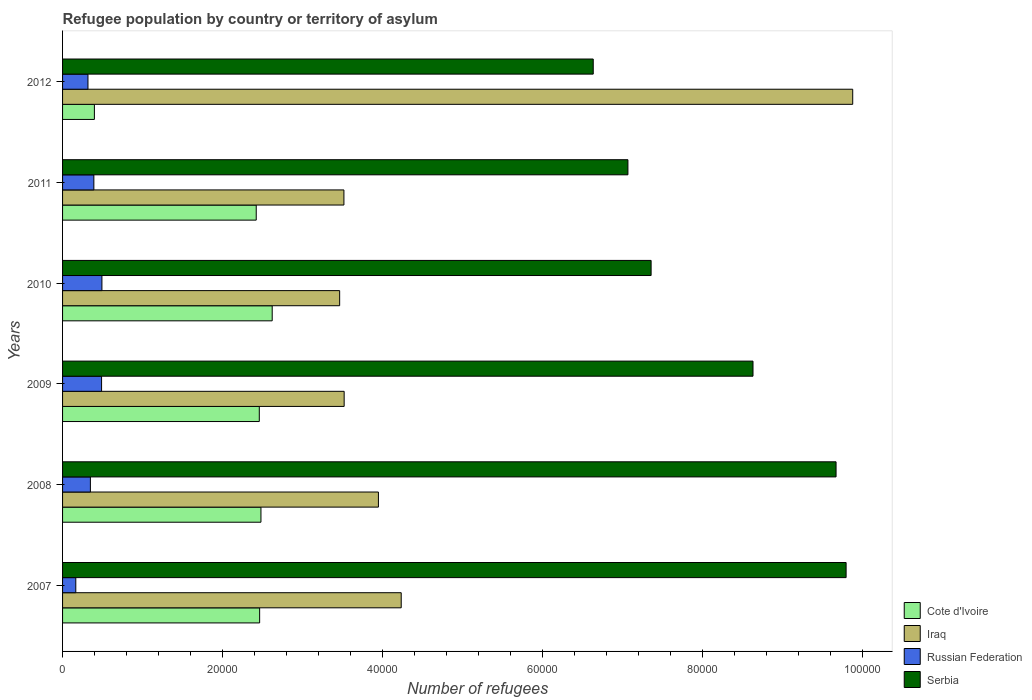How many groups of bars are there?
Your answer should be compact. 6. Are the number of bars per tick equal to the number of legend labels?
Offer a terse response. Yes. How many bars are there on the 5th tick from the top?
Your answer should be compact. 4. In how many cases, is the number of bars for a given year not equal to the number of legend labels?
Offer a very short reply. 0. What is the number of refugees in Iraq in 2009?
Offer a very short reply. 3.52e+04. Across all years, what is the maximum number of refugees in Russian Federation?
Make the answer very short. 4922. Across all years, what is the minimum number of refugees in Russian Federation?
Keep it short and to the point. 1655. What is the total number of refugees in Cote d'Ivoire in the graph?
Your answer should be very brief. 1.28e+05. What is the difference between the number of refugees in Cote d'Ivoire in 2009 and that in 2010?
Make the answer very short. -1614. What is the difference between the number of refugees in Serbia in 2010 and the number of refugees in Cote d'Ivoire in 2012?
Your response must be concise. 6.96e+04. What is the average number of refugees in Russian Federation per year?
Your answer should be compact. 3671.33. In the year 2008, what is the difference between the number of refugees in Russian Federation and number of refugees in Iraq?
Give a very brief answer. -3.60e+04. What is the ratio of the number of refugees in Cote d'Ivoire in 2007 to that in 2008?
Provide a short and direct response. 0.99. Is the number of refugees in Cote d'Ivoire in 2008 less than that in 2011?
Give a very brief answer. No. Is the difference between the number of refugees in Russian Federation in 2008 and 2012 greater than the difference between the number of refugees in Iraq in 2008 and 2012?
Provide a short and direct response. Yes. What is the difference between the highest and the second highest number of refugees in Serbia?
Give a very brief answer. 1256. What is the difference between the highest and the lowest number of refugees in Iraq?
Provide a short and direct response. 6.42e+04. In how many years, is the number of refugees in Iraq greater than the average number of refugees in Iraq taken over all years?
Give a very brief answer. 1. Is the sum of the number of refugees in Cote d'Ivoire in 2009 and 2011 greater than the maximum number of refugees in Iraq across all years?
Offer a very short reply. No. What does the 2nd bar from the top in 2008 represents?
Provide a succinct answer. Russian Federation. What does the 2nd bar from the bottom in 2008 represents?
Ensure brevity in your answer.  Iraq. Is it the case that in every year, the sum of the number of refugees in Iraq and number of refugees in Cote d'Ivoire is greater than the number of refugees in Russian Federation?
Ensure brevity in your answer.  Yes. How many bars are there?
Provide a short and direct response. 24. Are all the bars in the graph horizontal?
Your answer should be compact. Yes. Are the values on the major ticks of X-axis written in scientific E-notation?
Your answer should be compact. No. Does the graph contain grids?
Provide a short and direct response. No. Where does the legend appear in the graph?
Your answer should be compact. Bottom right. How many legend labels are there?
Your answer should be very brief. 4. How are the legend labels stacked?
Offer a terse response. Vertical. What is the title of the graph?
Give a very brief answer. Refugee population by country or territory of asylum. Does "Gabon" appear as one of the legend labels in the graph?
Keep it short and to the point. No. What is the label or title of the X-axis?
Your response must be concise. Number of refugees. What is the label or title of the Y-axis?
Provide a succinct answer. Years. What is the Number of refugees of Cote d'Ivoire in 2007?
Give a very brief answer. 2.46e+04. What is the Number of refugees in Iraq in 2007?
Provide a short and direct response. 4.24e+04. What is the Number of refugees of Russian Federation in 2007?
Offer a terse response. 1655. What is the Number of refugees of Serbia in 2007?
Keep it short and to the point. 9.80e+04. What is the Number of refugees in Cote d'Ivoire in 2008?
Provide a short and direct response. 2.48e+04. What is the Number of refugees in Iraq in 2008?
Provide a succinct answer. 3.95e+04. What is the Number of refugees of Russian Federation in 2008?
Your answer should be compact. 3479. What is the Number of refugees of Serbia in 2008?
Offer a very short reply. 9.67e+04. What is the Number of refugees in Cote d'Ivoire in 2009?
Your answer should be very brief. 2.46e+04. What is the Number of refugees of Iraq in 2009?
Your response must be concise. 3.52e+04. What is the Number of refugees in Russian Federation in 2009?
Offer a terse response. 4880. What is the Number of refugees in Serbia in 2009?
Ensure brevity in your answer.  8.64e+04. What is the Number of refugees of Cote d'Ivoire in 2010?
Make the answer very short. 2.62e+04. What is the Number of refugees of Iraq in 2010?
Give a very brief answer. 3.47e+04. What is the Number of refugees in Russian Federation in 2010?
Your answer should be very brief. 4922. What is the Number of refugees in Serbia in 2010?
Provide a short and direct response. 7.36e+04. What is the Number of refugees in Cote d'Ivoire in 2011?
Your response must be concise. 2.42e+04. What is the Number of refugees in Iraq in 2011?
Your answer should be compact. 3.52e+04. What is the Number of refugees in Russian Federation in 2011?
Keep it short and to the point. 3914. What is the Number of refugees in Serbia in 2011?
Provide a succinct answer. 7.07e+04. What is the Number of refugees of Cote d'Ivoire in 2012?
Your answer should be compact. 3980. What is the Number of refugees of Iraq in 2012?
Provide a succinct answer. 9.88e+04. What is the Number of refugees of Russian Federation in 2012?
Keep it short and to the point. 3178. What is the Number of refugees of Serbia in 2012?
Your answer should be compact. 6.64e+04. Across all years, what is the maximum Number of refugees of Cote d'Ivoire?
Make the answer very short. 2.62e+04. Across all years, what is the maximum Number of refugees of Iraq?
Give a very brief answer. 9.88e+04. Across all years, what is the maximum Number of refugees of Russian Federation?
Your answer should be compact. 4922. Across all years, what is the maximum Number of refugees in Serbia?
Your response must be concise. 9.80e+04. Across all years, what is the minimum Number of refugees in Cote d'Ivoire?
Keep it short and to the point. 3980. Across all years, what is the minimum Number of refugees of Iraq?
Provide a succinct answer. 3.47e+04. Across all years, what is the minimum Number of refugees of Russian Federation?
Ensure brevity in your answer.  1655. Across all years, what is the minimum Number of refugees of Serbia?
Your answer should be very brief. 6.64e+04. What is the total Number of refugees in Cote d'Ivoire in the graph?
Offer a very short reply. 1.28e+05. What is the total Number of refugees in Iraq in the graph?
Your response must be concise. 2.86e+05. What is the total Number of refugees of Russian Federation in the graph?
Give a very brief answer. 2.20e+04. What is the total Number of refugees of Serbia in the graph?
Offer a very short reply. 4.92e+05. What is the difference between the Number of refugees in Cote d'Ivoire in 2007 and that in 2008?
Your answer should be compact. -164. What is the difference between the Number of refugees of Iraq in 2007 and that in 2008?
Ensure brevity in your answer.  2851. What is the difference between the Number of refugees of Russian Federation in 2007 and that in 2008?
Ensure brevity in your answer.  -1824. What is the difference between the Number of refugees in Serbia in 2007 and that in 2008?
Your answer should be compact. 1256. What is the difference between the Number of refugees of Cote d'Ivoire in 2007 and that in 2009?
Provide a short and direct response. 43. What is the difference between the Number of refugees in Iraq in 2007 and that in 2009?
Make the answer very short. 7136. What is the difference between the Number of refugees in Russian Federation in 2007 and that in 2009?
Keep it short and to the point. -3225. What is the difference between the Number of refugees of Serbia in 2007 and that in 2009?
Your response must be concise. 1.16e+04. What is the difference between the Number of refugees in Cote d'Ivoire in 2007 and that in 2010?
Offer a very short reply. -1571. What is the difference between the Number of refugees in Iraq in 2007 and that in 2010?
Your answer should be very brief. 7699. What is the difference between the Number of refugees of Russian Federation in 2007 and that in 2010?
Offer a very short reply. -3267. What is the difference between the Number of refugees of Serbia in 2007 and that in 2010?
Give a very brief answer. 2.44e+04. What is the difference between the Number of refugees in Cote d'Ivoire in 2007 and that in 2011?
Provide a succinct answer. 426. What is the difference between the Number of refugees of Iraq in 2007 and that in 2011?
Your answer should be compact. 7165. What is the difference between the Number of refugees of Russian Federation in 2007 and that in 2011?
Offer a terse response. -2259. What is the difference between the Number of refugees of Serbia in 2007 and that in 2011?
Offer a very short reply. 2.73e+04. What is the difference between the Number of refugees in Cote d'Ivoire in 2007 and that in 2012?
Provide a short and direct response. 2.07e+04. What is the difference between the Number of refugees of Iraq in 2007 and that in 2012?
Offer a very short reply. -5.65e+04. What is the difference between the Number of refugees in Russian Federation in 2007 and that in 2012?
Make the answer very short. -1523. What is the difference between the Number of refugees of Serbia in 2007 and that in 2012?
Your response must be concise. 3.16e+04. What is the difference between the Number of refugees in Cote d'Ivoire in 2008 and that in 2009?
Your answer should be compact. 207. What is the difference between the Number of refugees in Iraq in 2008 and that in 2009?
Ensure brevity in your answer.  4285. What is the difference between the Number of refugees of Russian Federation in 2008 and that in 2009?
Provide a succinct answer. -1401. What is the difference between the Number of refugees in Serbia in 2008 and that in 2009?
Offer a terse response. 1.04e+04. What is the difference between the Number of refugees of Cote d'Ivoire in 2008 and that in 2010?
Your answer should be compact. -1407. What is the difference between the Number of refugees in Iraq in 2008 and that in 2010?
Keep it short and to the point. 4848. What is the difference between the Number of refugees in Russian Federation in 2008 and that in 2010?
Provide a short and direct response. -1443. What is the difference between the Number of refugees in Serbia in 2008 and that in 2010?
Your answer should be very brief. 2.31e+04. What is the difference between the Number of refugees of Cote d'Ivoire in 2008 and that in 2011?
Your answer should be very brief. 590. What is the difference between the Number of refugees of Iraq in 2008 and that in 2011?
Your answer should be very brief. 4314. What is the difference between the Number of refugees in Russian Federation in 2008 and that in 2011?
Your answer should be very brief. -435. What is the difference between the Number of refugees in Serbia in 2008 and that in 2011?
Provide a short and direct response. 2.60e+04. What is the difference between the Number of refugees of Cote d'Ivoire in 2008 and that in 2012?
Provide a succinct answer. 2.08e+04. What is the difference between the Number of refugees in Iraq in 2008 and that in 2012?
Provide a short and direct response. -5.93e+04. What is the difference between the Number of refugees in Russian Federation in 2008 and that in 2012?
Your answer should be compact. 301. What is the difference between the Number of refugees in Serbia in 2008 and that in 2012?
Provide a succinct answer. 3.04e+04. What is the difference between the Number of refugees in Cote d'Ivoire in 2009 and that in 2010?
Offer a terse response. -1614. What is the difference between the Number of refugees of Iraq in 2009 and that in 2010?
Keep it short and to the point. 563. What is the difference between the Number of refugees of Russian Federation in 2009 and that in 2010?
Give a very brief answer. -42. What is the difference between the Number of refugees of Serbia in 2009 and that in 2010?
Offer a terse response. 1.27e+04. What is the difference between the Number of refugees of Cote d'Ivoire in 2009 and that in 2011?
Offer a very short reply. 383. What is the difference between the Number of refugees in Iraq in 2009 and that in 2011?
Ensure brevity in your answer.  29. What is the difference between the Number of refugees of Russian Federation in 2009 and that in 2011?
Provide a short and direct response. 966. What is the difference between the Number of refugees of Serbia in 2009 and that in 2011?
Your response must be concise. 1.56e+04. What is the difference between the Number of refugees of Cote d'Ivoire in 2009 and that in 2012?
Ensure brevity in your answer.  2.06e+04. What is the difference between the Number of refugees in Iraq in 2009 and that in 2012?
Offer a very short reply. -6.36e+04. What is the difference between the Number of refugees of Russian Federation in 2009 and that in 2012?
Offer a terse response. 1702. What is the difference between the Number of refugees of Serbia in 2009 and that in 2012?
Offer a very short reply. 2.00e+04. What is the difference between the Number of refugees of Cote d'Ivoire in 2010 and that in 2011?
Make the answer very short. 1997. What is the difference between the Number of refugees in Iraq in 2010 and that in 2011?
Your response must be concise. -534. What is the difference between the Number of refugees in Russian Federation in 2010 and that in 2011?
Provide a short and direct response. 1008. What is the difference between the Number of refugees in Serbia in 2010 and that in 2011?
Make the answer very short. 2901. What is the difference between the Number of refugees in Cote d'Ivoire in 2010 and that in 2012?
Provide a short and direct response. 2.22e+04. What is the difference between the Number of refugees in Iraq in 2010 and that in 2012?
Offer a terse response. -6.42e+04. What is the difference between the Number of refugees of Russian Federation in 2010 and that in 2012?
Make the answer very short. 1744. What is the difference between the Number of refugees of Serbia in 2010 and that in 2012?
Give a very brief answer. 7238. What is the difference between the Number of refugees in Cote d'Ivoire in 2011 and that in 2012?
Your answer should be compact. 2.02e+04. What is the difference between the Number of refugees of Iraq in 2011 and that in 2012?
Your answer should be very brief. -6.36e+04. What is the difference between the Number of refugees in Russian Federation in 2011 and that in 2012?
Your answer should be compact. 736. What is the difference between the Number of refugees in Serbia in 2011 and that in 2012?
Ensure brevity in your answer.  4337. What is the difference between the Number of refugees of Cote d'Ivoire in 2007 and the Number of refugees of Iraq in 2008?
Your response must be concise. -1.49e+04. What is the difference between the Number of refugees of Cote d'Ivoire in 2007 and the Number of refugees of Russian Federation in 2008?
Give a very brief answer. 2.12e+04. What is the difference between the Number of refugees in Cote d'Ivoire in 2007 and the Number of refugees in Serbia in 2008?
Offer a very short reply. -7.21e+04. What is the difference between the Number of refugees in Iraq in 2007 and the Number of refugees in Russian Federation in 2008?
Offer a very short reply. 3.89e+04. What is the difference between the Number of refugees in Iraq in 2007 and the Number of refugees in Serbia in 2008?
Your response must be concise. -5.44e+04. What is the difference between the Number of refugees in Russian Federation in 2007 and the Number of refugees in Serbia in 2008?
Ensure brevity in your answer.  -9.51e+04. What is the difference between the Number of refugees of Cote d'Ivoire in 2007 and the Number of refugees of Iraq in 2009?
Ensure brevity in your answer.  -1.06e+04. What is the difference between the Number of refugees in Cote d'Ivoire in 2007 and the Number of refugees in Russian Federation in 2009?
Ensure brevity in your answer.  1.98e+04. What is the difference between the Number of refugees in Cote d'Ivoire in 2007 and the Number of refugees in Serbia in 2009?
Ensure brevity in your answer.  -6.17e+04. What is the difference between the Number of refugees in Iraq in 2007 and the Number of refugees in Russian Federation in 2009?
Your response must be concise. 3.75e+04. What is the difference between the Number of refugees of Iraq in 2007 and the Number of refugees of Serbia in 2009?
Keep it short and to the point. -4.40e+04. What is the difference between the Number of refugees of Russian Federation in 2007 and the Number of refugees of Serbia in 2009?
Ensure brevity in your answer.  -8.47e+04. What is the difference between the Number of refugees of Cote d'Ivoire in 2007 and the Number of refugees of Iraq in 2010?
Offer a terse response. -1.00e+04. What is the difference between the Number of refugees in Cote d'Ivoire in 2007 and the Number of refugees in Russian Federation in 2010?
Your answer should be very brief. 1.97e+04. What is the difference between the Number of refugees in Cote d'Ivoire in 2007 and the Number of refugees in Serbia in 2010?
Keep it short and to the point. -4.90e+04. What is the difference between the Number of refugees in Iraq in 2007 and the Number of refugees in Russian Federation in 2010?
Make the answer very short. 3.74e+04. What is the difference between the Number of refugees of Iraq in 2007 and the Number of refugees of Serbia in 2010?
Offer a terse response. -3.13e+04. What is the difference between the Number of refugees in Russian Federation in 2007 and the Number of refugees in Serbia in 2010?
Your answer should be very brief. -7.20e+04. What is the difference between the Number of refugees in Cote d'Ivoire in 2007 and the Number of refugees in Iraq in 2011?
Offer a terse response. -1.05e+04. What is the difference between the Number of refugees of Cote d'Ivoire in 2007 and the Number of refugees of Russian Federation in 2011?
Provide a short and direct response. 2.07e+04. What is the difference between the Number of refugees in Cote d'Ivoire in 2007 and the Number of refugees in Serbia in 2011?
Your response must be concise. -4.61e+04. What is the difference between the Number of refugees in Iraq in 2007 and the Number of refugees in Russian Federation in 2011?
Make the answer very short. 3.84e+04. What is the difference between the Number of refugees in Iraq in 2007 and the Number of refugees in Serbia in 2011?
Keep it short and to the point. -2.84e+04. What is the difference between the Number of refugees in Russian Federation in 2007 and the Number of refugees in Serbia in 2011?
Ensure brevity in your answer.  -6.91e+04. What is the difference between the Number of refugees in Cote d'Ivoire in 2007 and the Number of refugees in Iraq in 2012?
Your answer should be very brief. -7.42e+04. What is the difference between the Number of refugees of Cote d'Ivoire in 2007 and the Number of refugees of Russian Federation in 2012?
Make the answer very short. 2.15e+04. What is the difference between the Number of refugees in Cote d'Ivoire in 2007 and the Number of refugees in Serbia in 2012?
Ensure brevity in your answer.  -4.17e+04. What is the difference between the Number of refugees of Iraq in 2007 and the Number of refugees of Russian Federation in 2012?
Offer a very short reply. 3.92e+04. What is the difference between the Number of refugees of Iraq in 2007 and the Number of refugees of Serbia in 2012?
Offer a very short reply. -2.40e+04. What is the difference between the Number of refugees in Russian Federation in 2007 and the Number of refugees in Serbia in 2012?
Your response must be concise. -6.47e+04. What is the difference between the Number of refugees of Cote d'Ivoire in 2008 and the Number of refugees of Iraq in 2009?
Your answer should be very brief. -1.04e+04. What is the difference between the Number of refugees in Cote d'Ivoire in 2008 and the Number of refugees in Russian Federation in 2009?
Provide a succinct answer. 1.99e+04. What is the difference between the Number of refugees of Cote d'Ivoire in 2008 and the Number of refugees of Serbia in 2009?
Your answer should be compact. -6.15e+04. What is the difference between the Number of refugees of Iraq in 2008 and the Number of refugees of Russian Federation in 2009?
Offer a terse response. 3.46e+04. What is the difference between the Number of refugees in Iraq in 2008 and the Number of refugees in Serbia in 2009?
Offer a terse response. -4.68e+04. What is the difference between the Number of refugees of Russian Federation in 2008 and the Number of refugees of Serbia in 2009?
Ensure brevity in your answer.  -8.29e+04. What is the difference between the Number of refugees in Cote d'Ivoire in 2008 and the Number of refugees in Iraq in 2010?
Give a very brief answer. -9844. What is the difference between the Number of refugees in Cote d'Ivoire in 2008 and the Number of refugees in Russian Federation in 2010?
Offer a terse response. 1.99e+04. What is the difference between the Number of refugees of Cote d'Ivoire in 2008 and the Number of refugees of Serbia in 2010?
Offer a very short reply. -4.88e+04. What is the difference between the Number of refugees of Iraq in 2008 and the Number of refugees of Russian Federation in 2010?
Offer a very short reply. 3.46e+04. What is the difference between the Number of refugees of Iraq in 2008 and the Number of refugees of Serbia in 2010?
Keep it short and to the point. -3.41e+04. What is the difference between the Number of refugees in Russian Federation in 2008 and the Number of refugees in Serbia in 2010?
Your answer should be compact. -7.01e+04. What is the difference between the Number of refugees in Cote d'Ivoire in 2008 and the Number of refugees in Iraq in 2011?
Provide a short and direct response. -1.04e+04. What is the difference between the Number of refugees in Cote d'Ivoire in 2008 and the Number of refugees in Russian Federation in 2011?
Your answer should be very brief. 2.09e+04. What is the difference between the Number of refugees of Cote d'Ivoire in 2008 and the Number of refugees of Serbia in 2011?
Your answer should be very brief. -4.59e+04. What is the difference between the Number of refugees in Iraq in 2008 and the Number of refugees in Russian Federation in 2011?
Make the answer very short. 3.56e+04. What is the difference between the Number of refugees of Iraq in 2008 and the Number of refugees of Serbia in 2011?
Offer a terse response. -3.12e+04. What is the difference between the Number of refugees in Russian Federation in 2008 and the Number of refugees in Serbia in 2011?
Offer a terse response. -6.72e+04. What is the difference between the Number of refugees in Cote d'Ivoire in 2008 and the Number of refugees in Iraq in 2012?
Ensure brevity in your answer.  -7.40e+04. What is the difference between the Number of refugees in Cote d'Ivoire in 2008 and the Number of refugees in Russian Federation in 2012?
Make the answer very short. 2.16e+04. What is the difference between the Number of refugees of Cote d'Ivoire in 2008 and the Number of refugees of Serbia in 2012?
Your answer should be very brief. -4.16e+04. What is the difference between the Number of refugees of Iraq in 2008 and the Number of refugees of Russian Federation in 2012?
Give a very brief answer. 3.63e+04. What is the difference between the Number of refugees in Iraq in 2008 and the Number of refugees in Serbia in 2012?
Offer a very short reply. -2.69e+04. What is the difference between the Number of refugees of Russian Federation in 2008 and the Number of refugees of Serbia in 2012?
Give a very brief answer. -6.29e+04. What is the difference between the Number of refugees of Cote d'Ivoire in 2009 and the Number of refugees of Iraq in 2010?
Your answer should be compact. -1.01e+04. What is the difference between the Number of refugees of Cote d'Ivoire in 2009 and the Number of refugees of Russian Federation in 2010?
Provide a short and direct response. 1.97e+04. What is the difference between the Number of refugees in Cote d'Ivoire in 2009 and the Number of refugees in Serbia in 2010?
Keep it short and to the point. -4.90e+04. What is the difference between the Number of refugees in Iraq in 2009 and the Number of refugees in Russian Federation in 2010?
Provide a short and direct response. 3.03e+04. What is the difference between the Number of refugees of Iraq in 2009 and the Number of refugees of Serbia in 2010?
Offer a very short reply. -3.84e+04. What is the difference between the Number of refugees in Russian Federation in 2009 and the Number of refugees in Serbia in 2010?
Ensure brevity in your answer.  -6.87e+04. What is the difference between the Number of refugees of Cote d'Ivoire in 2009 and the Number of refugees of Iraq in 2011?
Offer a very short reply. -1.06e+04. What is the difference between the Number of refugees of Cote d'Ivoire in 2009 and the Number of refugees of Russian Federation in 2011?
Offer a very short reply. 2.07e+04. What is the difference between the Number of refugees in Cote d'Ivoire in 2009 and the Number of refugees in Serbia in 2011?
Give a very brief answer. -4.61e+04. What is the difference between the Number of refugees of Iraq in 2009 and the Number of refugees of Russian Federation in 2011?
Keep it short and to the point. 3.13e+04. What is the difference between the Number of refugees of Iraq in 2009 and the Number of refugees of Serbia in 2011?
Provide a succinct answer. -3.55e+04. What is the difference between the Number of refugees in Russian Federation in 2009 and the Number of refugees in Serbia in 2011?
Give a very brief answer. -6.58e+04. What is the difference between the Number of refugees in Cote d'Ivoire in 2009 and the Number of refugees in Iraq in 2012?
Provide a short and direct response. -7.42e+04. What is the difference between the Number of refugees of Cote d'Ivoire in 2009 and the Number of refugees of Russian Federation in 2012?
Offer a very short reply. 2.14e+04. What is the difference between the Number of refugees of Cote d'Ivoire in 2009 and the Number of refugees of Serbia in 2012?
Offer a terse response. -4.18e+04. What is the difference between the Number of refugees of Iraq in 2009 and the Number of refugees of Russian Federation in 2012?
Your response must be concise. 3.20e+04. What is the difference between the Number of refugees in Iraq in 2009 and the Number of refugees in Serbia in 2012?
Provide a succinct answer. -3.12e+04. What is the difference between the Number of refugees of Russian Federation in 2009 and the Number of refugees of Serbia in 2012?
Your answer should be compact. -6.15e+04. What is the difference between the Number of refugees in Cote d'Ivoire in 2010 and the Number of refugees in Iraq in 2011?
Your response must be concise. -8971. What is the difference between the Number of refugees in Cote d'Ivoire in 2010 and the Number of refugees in Russian Federation in 2011?
Your response must be concise. 2.23e+04. What is the difference between the Number of refugees of Cote d'Ivoire in 2010 and the Number of refugees of Serbia in 2011?
Your response must be concise. -4.45e+04. What is the difference between the Number of refugees in Iraq in 2010 and the Number of refugees in Russian Federation in 2011?
Offer a very short reply. 3.07e+04. What is the difference between the Number of refugees of Iraq in 2010 and the Number of refugees of Serbia in 2011?
Your answer should be very brief. -3.61e+04. What is the difference between the Number of refugees in Russian Federation in 2010 and the Number of refugees in Serbia in 2011?
Your answer should be compact. -6.58e+04. What is the difference between the Number of refugees in Cote d'Ivoire in 2010 and the Number of refugees in Iraq in 2012?
Your response must be concise. -7.26e+04. What is the difference between the Number of refugees of Cote d'Ivoire in 2010 and the Number of refugees of Russian Federation in 2012?
Your answer should be very brief. 2.30e+04. What is the difference between the Number of refugees of Cote d'Ivoire in 2010 and the Number of refugees of Serbia in 2012?
Offer a terse response. -4.02e+04. What is the difference between the Number of refugees in Iraq in 2010 and the Number of refugees in Russian Federation in 2012?
Your answer should be very brief. 3.15e+04. What is the difference between the Number of refugees of Iraq in 2010 and the Number of refugees of Serbia in 2012?
Make the answer very short. -3.17e+04. What is the difference between the Number of refugees of Russian Federation in 2010 and the Number of refugees of Serbia in 2012?
Ensure brevity in your answer.  -6.14e+04. What is the difference between the Number of refugees in Cote d'Ivoire in 2011 and the Number of refugees in Iraq in 2012?
Keep it short and to the point. -7.46e+04. What is the difference between the Number of refugees of Cote d'Ivoire in 2011 and the Number of refugees of Russian Federation in 2012?
Offer a terse response. 2.10e+04. What is the difference between the Number of refugees of Cote d'Ivoire in 2011 and the Number of refugees of Serbia in 2012?
Your answer should be compact. -4.21e+04. What is the difference between the Number of refugees of Iraq in 2011 and the Number of refugees of Russian Federation in 2012?
Provide a succinct answer. 3.20e+04. What is the difference between the Number of refugees of Iraq in 2011 and the Number of refugees of Serbia in 2012?
Give a very brief answer. -3.12e+04. What is the difference between the Number of refugees in Russian Federation in 2011 and the Number of refugees in Serbia in 2012?
Keep it short and to the point. -6.25e+04. What is the average Number of refugees in Cote d'Ivoire per year?
Give a very brief answer. 2.14e+04. What is the average Number of refugees of Iraq per year?
Offer a terse response. 4.76e+04. What is the average Number of refugees of Russian Federation per year?
Your answer should be compact. 3671.33. What is the average Number of refugees in Serbia per year?
Ensure brevity in your answer.  8.20e+04. In the year 2007, what is the difference between the Number of refugees of Cote d'Ivoire and Number of refugees of Iraq?
Make the answer very short. -1.77e+04. In the year 2007, what is the difference between the Number of refugees in Cote d'Ivoire and Number of refugees in Russian Federation?
Offer a very short reply. 2.30e+04. In the year 2007, what is the difference between the Number of refugees of Cote d'Ivoire and Number of refugees of Serbia?
Your answer should be very brief. -7.33e+04. In the year 2007, what is the difference between the Number of refugees in Iraq and Number of refugees in Russian Federation?
Keep it short and to the point. 4.07e+04. In the year 2007, what is the difference between the Number of refugees of Iraq and Number of refugees of Serbia?
Offer a terse response. -5.56e+04. In the year 2007, what is the difference between the Number of refugees of Russian Federation and Number of refugees of Serbia?
Provide a succinct answer. -9.63e+04. In the year 2008, what is the difference between the Number of refugees of Cote d'Ivoire and Number of refugees of Iraq?
Provide a short and direct response. -1.47e+04. In the year 2008, what is the difference between the Number of refugees of Cote d'Ivoire and Number of refugees of Russian Federation?
Offer a terse response. 2.13e+04. In the year 2008, what is the difference between the Number of refugees of Cote d'Ivoire and Number of refugees of Serbia?
Ensure brevity in your answer.  -7.19e+04. In the year 2008, what is the difference between the Number of refugees in Iraq and Number of refugees in Russian Federation?
Make the answer very short. 3.60e+04. In the year 2008, what is the difference between the Number of refugees in Iraq and Number of refugees in Serbia?
Provide a succinct answer. -5.72e+04. In the year 2008, what is the difference between the Number of refugees of Russian Federation and Number of refugees of Serbia?
Make the answer very short. -9.33e+04. In the year 2009, what is the difference between the Number of refugees of Cote d'Ivoire and Number of refugees of Iraq?
Keep it short and to the point. -1.06e+04. In the year 2009, what is the difference between the Number of refugees of Cote d'Ivoire and Number of refugees of Russian Federation?
Make the answer very short. 1.97e+04. In the year 2009, what is the difference between the Number of refugees in Cote d'Ivoire and Number of refugees in Serbia?
Give a very brief answer. -6.17e+04. In the year 2009, what is the difference between the Number of refugees of Iraq and Number of refugees of Russian Federation?
Ensure brevity in your answer.  3.03e+04. In the year 2009, what is the difference between the Number of refugees of Iraq and Number of refugees of Serbia?
Offer a very short reply. -5.11e+04. In the year 2009, what is the difference between the Number of refugees in Russian Federation and Number of refugees in Serbia?
Provide a short and direct response. -8.15e+04. In the year 2010, what is the difference between the Number of refugees of Cote d'Ivoire and Number of refugees of Iraq?
Make the answer very short. -8437. In the year 2010, what is the difference between the Number of refugees in Cote d'Ivoire and Number of refugees in Russian Federation?
Offer a very short reply. 2.13e+04. In the year 2010, what is the difference between the Number of refugees in Cote d'Ivoire and Number of refugees in Serbia?
Ensure brevity in your answer.  -4.74e+04. In the year 2010, what is the difference between the Number of refugees in Iraq and Number of refugees in Russian Federation?
Offer a very short reply. 2.97e+04. In the year 2010, what is the difference between the Number of refugees in Iraq and Number of refugees in Serbia?
Offer a terse response. -3.90e+04. In the year 2010, what is the difference between the Number of refugees in Russian Federation and Number of refugees in Serbia?
Your answer should be compact. -6.87e+04. In the year 2011, what is the difference between the Number of refugees in Cote d'Ivoire and Number of refugees in Iraq?
Your response must be concise. -1.10e+04. In the year 2011, what is the difference between the Number of refugees of Cote d'Ivoire and Number of refugees of Russian Federation?
Provide a short and direct response. 2.03e+04. In the year 2011, what is the difference between the Number of refugees of Cote d'Ivoire and Number of refugees of Serbia?
Make the answer very short. -4.65e+04. In the year 2011, what is the difference between the Number of refugees in Iraq and Number of refugees in Russian Federation?
Offer a very short reply. 3.13e+04. In the year 2011, what is the difference between the Number of refugees in Iraq and Number of refugees in Serbia?
Give a very brief answer. -3.55e+04. In the year 2011, what is the difference between the Number of refugees in Russian Federation and Number of refugees in Serbia?
Your answer should be very brief. -6.68e+04. In the year 2012, what is the difference between the Number of refugees in Cote d'Ivoire and Number of refugees in Iraq?
Ensure brevity in your answer.  -9.48e+04. In the year 2012, what is the difference between the Number of refugees of Cote d'Ivoire and Number of refugees of Russian Federation?
Provide a short and direct response. 802. In the year 2012, what is the difference between the Number of refugees in Cote d'Ivoire and Number of refugees in Serbia?
Ensure brevity in your answer.  -6.24e+04. In the year 2012, what is the difference between the Number of refugees in Iraq and Number of refugees in Russian Federation?
Offer a terse response. 9.56e+04. In the year 2012, what is the difference between the Number of refugees in Iraq and Number of refugees in Serbia?
Provide a short and direct response. 3.25e+04. In the year 2012, what is the difference between the Number of refugees of Russian Federation and Number of refugees of Serbia?
Ensure brevity in your answer.  -6.32e+04. What is the ratio of the Number of refugees of Cote d'Ivoire in 2007 to that in 2008?
Offer a very short reply. 0.99. What is the ratio of the Number of refugees in Iraq in 2007 to that in 2008?
Make the answer very short. 1.07. What is the ratio of the Number of refugees in Russian Federation in 2007 to that in 2008?
Your response must be concise. 0.48. What is the ratio of the Number of refugees in Cote d'Ivoire in 2007 to that in 2009?
Offer a very short reply. 1. What is the ratio of the Number of refugees of Iraq in 2007 to that in 2009?
Give a very brief answer. 1.2. What is the ratio of the Number of refugees of Russian Federation in 2007 to that in 2009?
Your response must be concise. 0.34. What is the ratio of the Number of refugees of Serbia in 2007 to that in 2009?
Provide a succinct answer. 1.13. What is the ratio of the Number of refugees in Cote d'Ivoire in 2007 to that in 2010?
Your answer should be compact. 0.94. What is the ratio of the Number of refugees in Iraq in 2007 to that in 2010?
Your answer should be very brief. 1.22. What is the ratio of the Number of refugees in Russian Federation in 2007 to that in 2010?
Ensure brevity in your answer.  0.34. What is the ratio of the Number of refugees of Serbia in 2007 to that in 2010?
Offer a very short reply. 1.33. What is the ratio of the Number of refugees of Cote d'Ivoire in 2007 to that in 2011?
Provide a succinct answer. 1.02. What is the ratio of the Number of refugees in Iraq in 2007 to that in 2011?
Your answer should be compact. 1.2. What is the ratio of the Number of refugees of Russian Federation in 2007 to that in 2011?
Your answer should be very brief. 0.42. What is the ratio of the Number of refugees in Serbia in 2007 to that in 2011?
Make the answer very short. 1.39. What is the ratio of the Number of refugees of Cote d'Ivoire in 2007 to that in 2012?
Keep it short and to the point. 6.19. What is the ratio of the Number of refugees of Iraq in 2007 to that in 2012?
Your answer should be compact. 0.43. What is the ratio of the Number of refugees of Russian Federation in 2007 to that in 2012?
Offer a terse response. 0.52. What is the ratio of the Number of refugees in Serbia in 2007 to that in 2012?
Provide a short and direct response. 1.48. What is the ratio of the Number of refugees of Cote d'Ivoire in 2008 to that in 2009?
Keep it short and to the point. 1.01. What is the ratio of the Number of refugees of Iraq in 2008 to that in 2009?
Your answer should be compact. 1.12. What is the ratio of the Number of refugees in Russian Federation in 2008 to that in 2009?
Provide a succinct answer. 0.71. What is the ratio of the Number of refugees in Serbia in 2008 to that in 2009?
Provide a short and direct response. 1.12. What is the ratio of the Number of refugees in Cote d'Ivoire in 2008 to that in 2010?
Ensure brevity in your answer.  0.95. What is the ratio of the Number of refugees of Iraq in 2008 to that in 2010?
Ensure brevity in your answer.  1.14. What is the ratio of the Number of refugees of Russian Federation in 2008 to that in 2010?
Provide a succinct answer. 0.71. What is the ratio of the Number of refugees of Serbia in 2008 to that in 2010?
Your response must be concise. 1.31. What is the ratio of the Number of refugees of Cote d'Ivoire in 2008 to that in 2011?
Your response must be concise. 1.02. What is the ratio of the Number of refugees of Iraq in 2008 to that in 2011?
Provide a succinct answer. 1.12. What is the ratio of the Number of refugees of Russian Federation in 2008 to that in 2011?
Provide a succinct answer. 0.89. What is the ratio of the Number of refugees of Serbia in 2008 to that in 2011?
Provide a short and direct response. 1.37. What is the ratio of the Number of refugees in Cote d'Ivoire in 2008 to that in 2012?
Keep it short and to the point. 6.23. What is the ratio of the Number of refugees in Iraq in 2008 to that in 2012?
Offer a very short reply. 0.4. What is the ratio of the Number of refugees in Russian Federation in 2008 to that in 2012?
Make the answer very short. 1.09. What is the ratio of the Number of refugees in Serbia in 2008 to that in 2012?
Ensure brevity in your answer.  1.46. What is the ratio of the Number of refugees of Cote d'Ivoire in 2009 to that in 2010?
Give a very brief answer. 0.94. What is the ratio of the Number of refugees of Iraq in 2009 to that in 2010?
Make the answer very short. 1.02. What is the ratio of the Number of refugees of Serbia in 2009 to that in 2010?
Offer a very short reply. 1.17. What is the ratio of the Number of refugees of Cote d'Ivoire in 2009 to that in 2011?
Your answer should be very brief. 1.02. What is the ratio of the Number of refugees in Iraq in 2009 to that in 2011?
Your response must be concise. 1. What is the ratio of the Number of refugees of Russian Federation in 2009 to that in 2011?
Your answer should be very brief. 1.25. What is the ratio of the Number of refugees of Serbia in 2009 to that in 2011?
Offer a very short reply. 1.22. What is the ratio of the Number of refugees of Cote d'Ivoire in 2009 to that in 2012?
Your answer should be very brief. 6.18. What is the ratio of the Number of refugees in Iraq in 2009 to that in 2012?
Offer a terse response. 0.36. What is the ratio of the Number of refugees of Russian Federation in 2009 to that in 2012?
Provide a short and direct response. 1.54. What is the ratio of the Number of refugees of Serbia in 2009 to that in 2012?
Your answer should be very brief. 1.3. What is the ratio of the Number of refugees in Cote d'Ivoire in 2010 to that in 2011?
Make the answer very short. 1.08. What is the ratio of the Number of refugees in Iraq in 2010 to that in 2011?
Your answer should be compact. 0.98. What is the ratio of the Number of refugees of Russian Federation in 2010 to that in 2011?
Your answer should be compact. 1.26. What is the ratio of the Number of refugees of Serbia in 2010 to that in 2011?
Ensure brevity in your answer.  1.04. What is the ratio of the Number of refugees of Cote d'Ivoire in 2010 to that in 2012?
Keep it short and to the point. 6.59. What is the ratio of the Number of refugees in Iraq in 2010 to that in 2012?
Provide a succinct answer. 0.35. What is the ratio of the Number of refugees of Russian Federation in 2010 to that in 2012?
Keep it short and to the point. 1.55. What is the ratio of the Number of refugees in Serbia in 2010 to that in 2012?
Provide a short and direct response. 1.11. What is the ratio of the Number of refugees of Cote d'Ivoire in 2011 to that in 2012?
Ensure brevity in your answer.  6.09. What is the ratio of the Number of refugees of Iraq in 2011 to that in 2012?
Your response must be concise. 0.36. What is the ratio of the Number of refugees of Russian Federation in 2011 to that in 2012?
Offer a terse response. 1.23. What is the ratio of the Number of refugees in Serbia in 2011 to that in 2012?
Make the answer very short. 1.07. What is the difference between the highest and the second highest Number of refugees in Cote d'Ivoire?
Give a very brief answer. 1407. What is the difference between the highest and the second highest Number of refugees in Iraq?
Your response must be concise. 5.65e+04. What is the difference between the highest and the second highest Number of refugees of Russian Federation?
Provide a succinct answer. 42. What is the difference between the highest and the second highest Number of refugees in Serbia?
Offer a very short reply. 1256. What is the difference between the highest and the lowest Number of refugees in Cote d'Ivoire?
Offer a very short reply. 2.22e+04. What is the difference between the highest and the lowest Number of refugees in Iraq?
Ensure brevity in your answer.  6.42e+04. What is the difference between the highest and the lowest Number of refugees of Russian Federation?
Your answer should be very brief. 3267. What is the difference between the highest and the lowest Number of refugees of Serbia?
Provide a succinct answer. 3.16e+04. 